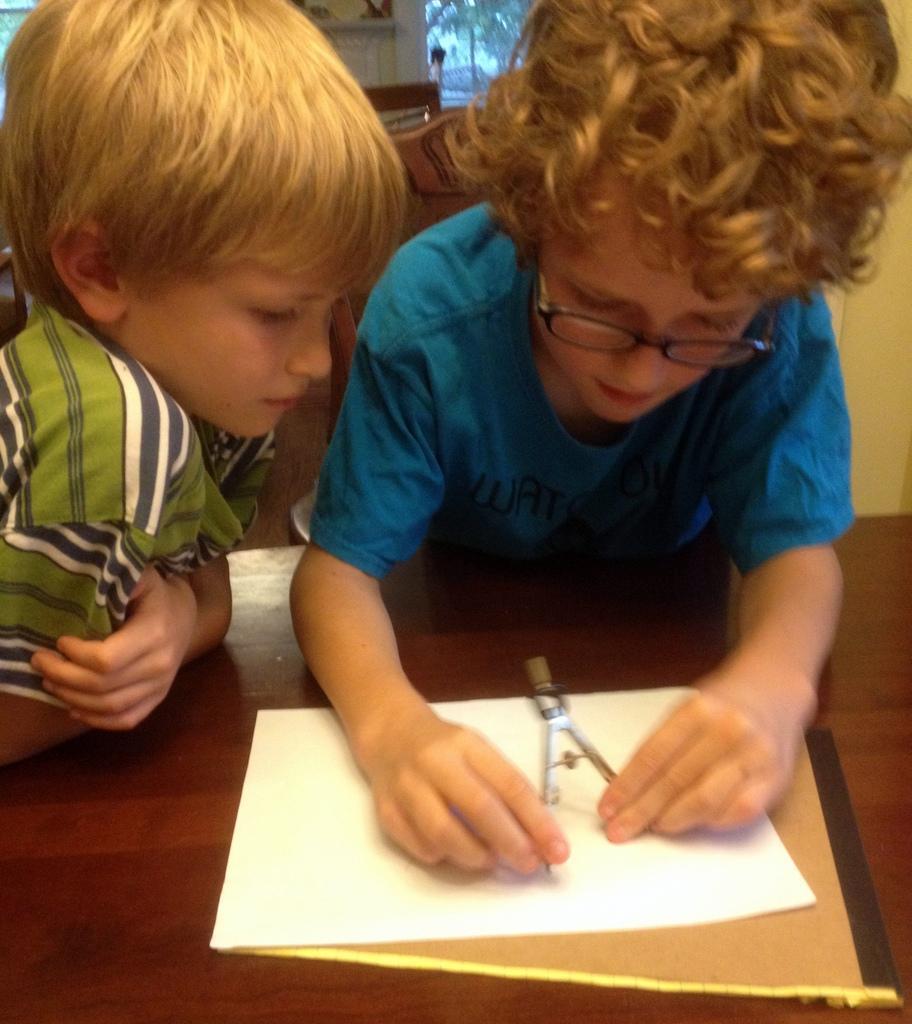Describe this image in one or two sentences. In this image I can see two kids. I can see a paper and a book on the table. 